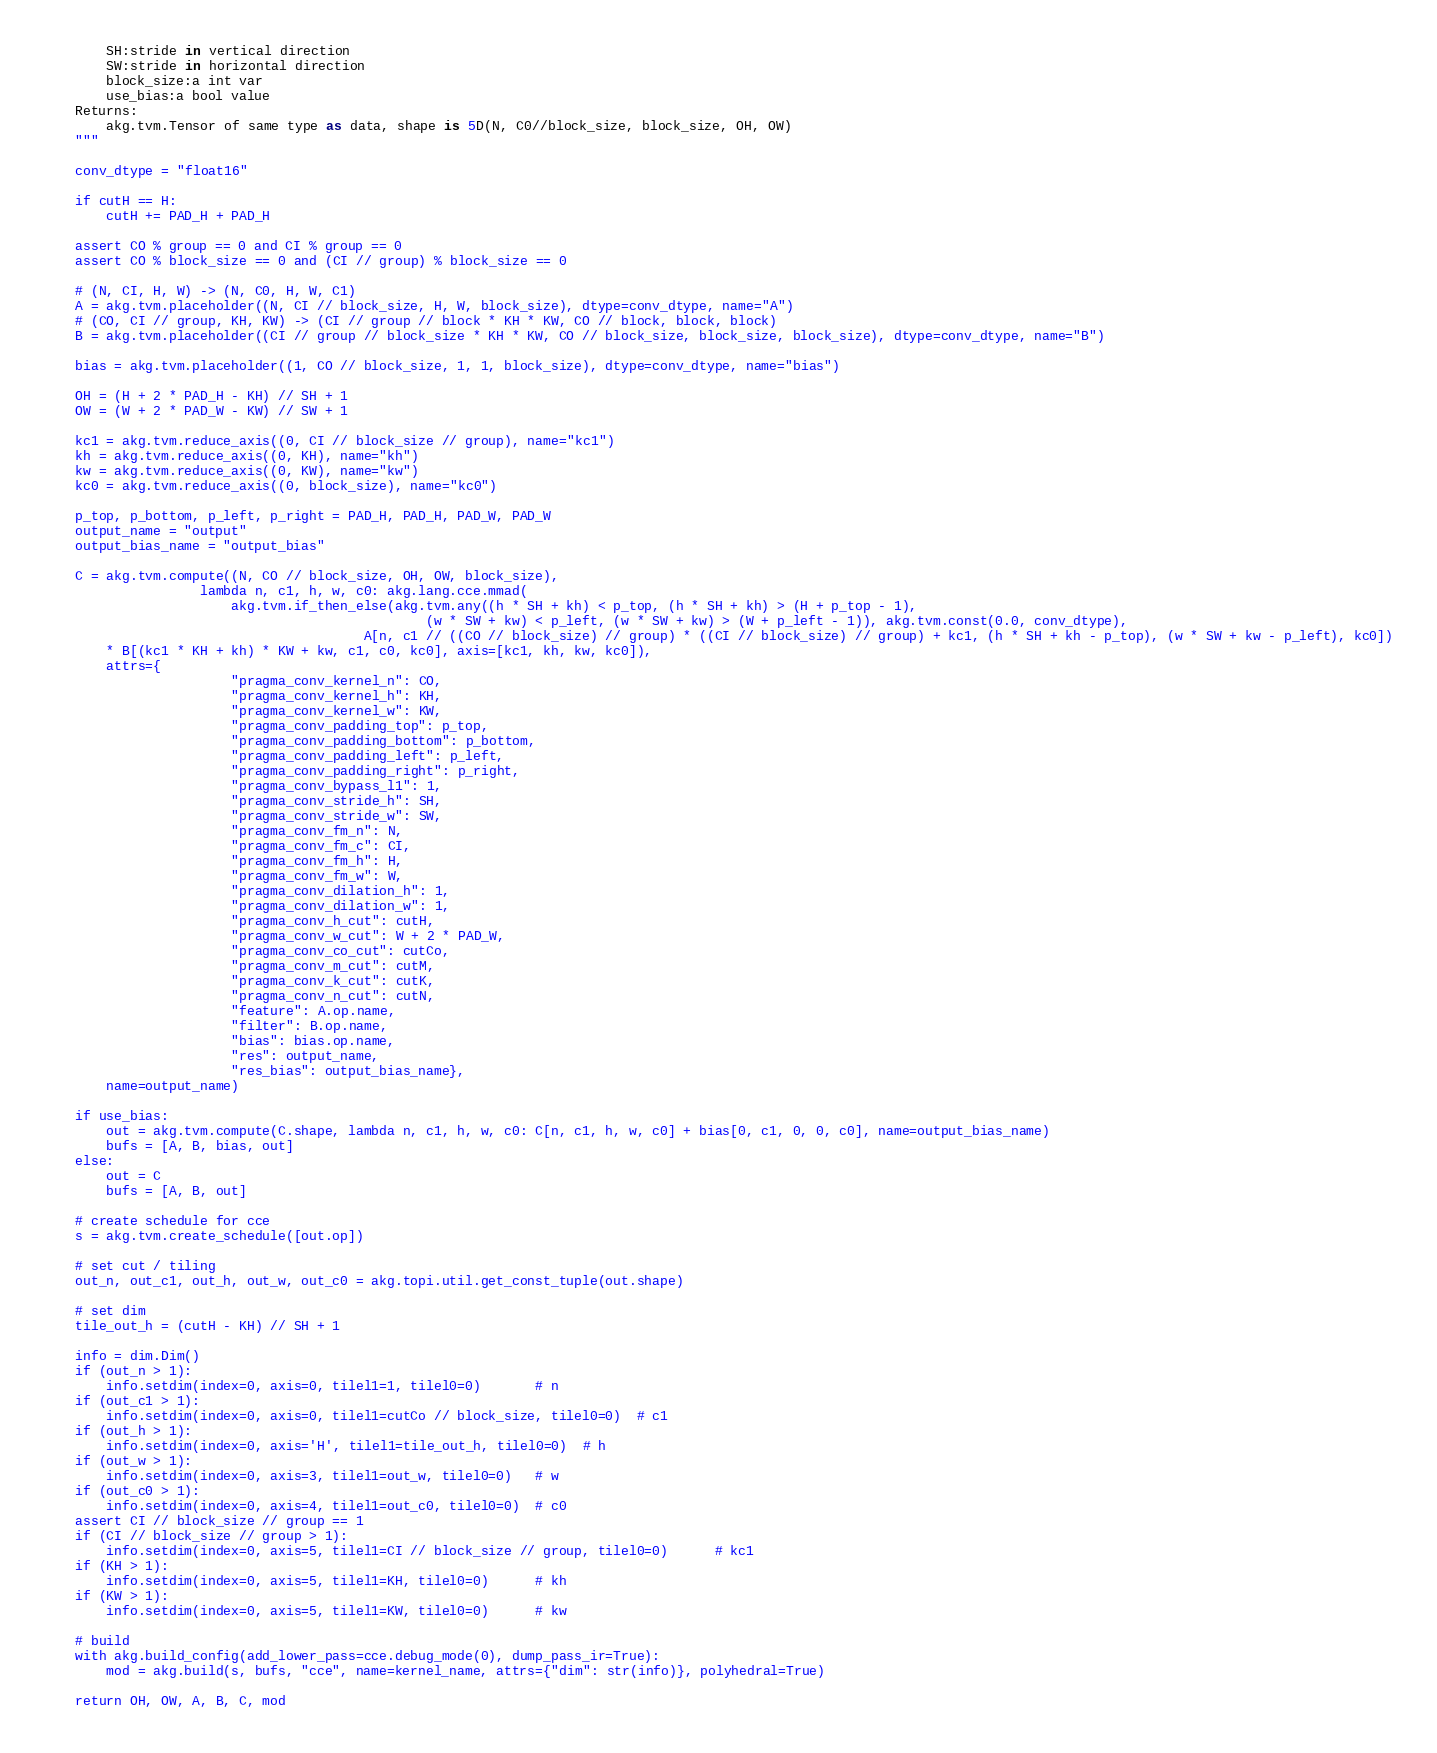<code> <loc_0><loc_0><loc_500><loc_500><_Python_>        SH:stride in vertical direction
        SW:stride in horizontal direction
        block_size:a int var
        use_bias:a bool value
    Returns:
        akg.tvm.Tensor of same type as data, shape is 5D(N, C0//block_size, block_size, OH, OW)
    """

    conv_dtype = "float16"

    if cutH == H:
        cutH += PAD_H + PAD_H

    assert CO % group == 0 and CI % group == 0
    assert CO % block_size == 0 and (CI // group) % block_size == 0

    # (N, CI, H, W) -> (N, C0, H, W, C1)
    A = akg.tvm.placeholder((N, CI // block_size, H, W, block_size), dtype=conv_dtype, name="A")
    # (CO, CI // group, KH, KW) -> (CI // group // block * KH * KW, CO // block, block, block)
    B = akg.tvm.placeholder((CI // group // block_size * KH * KW, CO // block_size, block_size, block_size), dtype=conv_dtype, name="B")

    bias = akg.tvm.placeholder((1, CO // block_size, 1, 1, block_size), dtype=conv_dtype, name="bias")

    OH = (H + 2 * PAD_H - KH) // SH + 1
    OW = (W + 2 * PAD_W - KW) // SW + 1

    kc1 = akg.tvm.reduce_axis((0, CI // block_size // group), name="kc1")
    kh = akg.tvm.reduce_axis((0, KH), name="kh")
    kw = akg.tvm.reduce_axis((0, KW), name="kw")
    kc0 = akg.tvm.reduce_axis((0, block_size), name="kc0")

    p_top, p_bottom, p_left, p_right = PAD_H, PAD_H, PAD_W, PAD_W
    output_name = "output"
    output_bias_name = "output_bias"

    C = akg.tvm.compute((N, CO // block_size, OH, OW, block_size),
                    lambda n, c1, h, w, c0: akg.lang.cce.mmad(
                        akg.tvm.if_then_else(akg.tvm.any((h * SH + kh) < p_top, (h * SH + kh) > (H + p_top - 1),
                                                 (w * SW + kw) < p_left, (w * SW + kw) > (W + p_left - 1)), akg.tvm.const(0.0, conv_dtype),
                                         A[n, c1 // ((CO // block_size) // group) * ((CI // block_size) // group) + kc1, (h * SH + kh - p_top), (w * SW + kw - p_left), kc0])
        * B[(kc1 * KH + kh) * KW + kw, c1, c0, kc0], axis=[kc1, kh, kw, kc0]),
        attrs={
                        "pragma_conv_kernel_n": CO,
                        "pragma_conv_kernel_h": KH,
                        "pragma_conv_kernel_w": KW,
                        "pragma_conv_padding_top": p_top,
                        "pragma_conv_padding_bottom": p_bottom,
                        "pragma_conv_padding_left": p_left,
                        "pragma_conv_padding_right": p_right,
                        "pragma_conv_bypass_l1": 1,
                        "pragma_conv_stride_h": SH,
                        "pragma_conv_stride_w": SW,
                        "pragma_conv_fm_n": N,
                        "pragma_conv_fm_c": CI,
                        "pragma_conv_fm_h": H,
                        "pragma_conv_fm_w": W,
                        "pragma_conv_dilation_h": 1,
                        "pragma_conv_dilation_w": 1,
                        "pragma_conv_h_cut": cutH,
                        "pragma_conv_w_cut": W + 2 * PAD_W,
                        "pragma_conv_co_cut": cutCo,
                        "pragma_conv_m_cut": cutM,
                        "pragma_conv_k_cut": cutK,
                        "pragma_conv_n_cut": cutN,
                        "feature": A.op.name,
                        "filter": B.op.name,
                        "bias": bias.op.name,
                        "res": output_name,
                        "res_bias": output_bias_name},
        name=output_name)

    if use_bias:
        out = akg.tvm.compute(C.shape, lambda n, c1, h, w, c0: C[n, c1, h, w, c0] + bias[0, c1, 0, 0, c0], name=output_bias_name)
        bufs = [A, B, bias, out]
    else:
        out = C
        bufs = [A, B, out]

    # create schedule for cce
    s = akg.tvm.create_schedule([out.op])

    # set cut / tiling
    out_n, out_c1, out_h, out_w, out_c0 = akg.topi.util.get_const_tuple(out.shape)

    # set dim
    tile_out_h = (cutH - KH) // SH + 1

    info = dim.Dim()
    if (out_n > 1):
        info.setdim(index=0, axis=0, tilel1=1, tilel0=0)       # n
    if (out_c1 > 1):
        info.setdim(index=0, axis=0, tilel1=cutCo // block_size, tilel0=0)  # c1
    if (out_h > 1):
        info.setdim(index=0, axis='H', tilel1=tile_out_h, tilel0=0)  # h
    if (out_w > 1):
        info.setdim(index=0, axis=3, tilel1=out_w, tilel0=0)   # w
    if (out_c0 > 1):
        info.setdim(index=0, axis=4, tilel1=out_c0, tilel0=0)  # c0
    assert CI // block_size // group == 1
    if (CI // block_size // group > 1):
        info.setdim(index=0, axis=5, tilel1=CI // block_size // group, tilel0=0)      # kc1
    if (KH > 1):
        info.setdim(index=0, axis=5, tilel1=KH, tilel0=0)      # kh
    if (KW > 1):
        info.setdim(index=0, axis=5, tilel1=KW, tilel0=0)      # kw

    # build
    with akg.build_config(add_lower_pass=cce.debug_mode(0), dump_pass_ir=True):
        mod = akg.build(s, bufs, "cce", name=kernel_name, attrs={"dim": str(info)}, polyhedral=True)

    return OH, OW, A, B, C, mod
</code> 